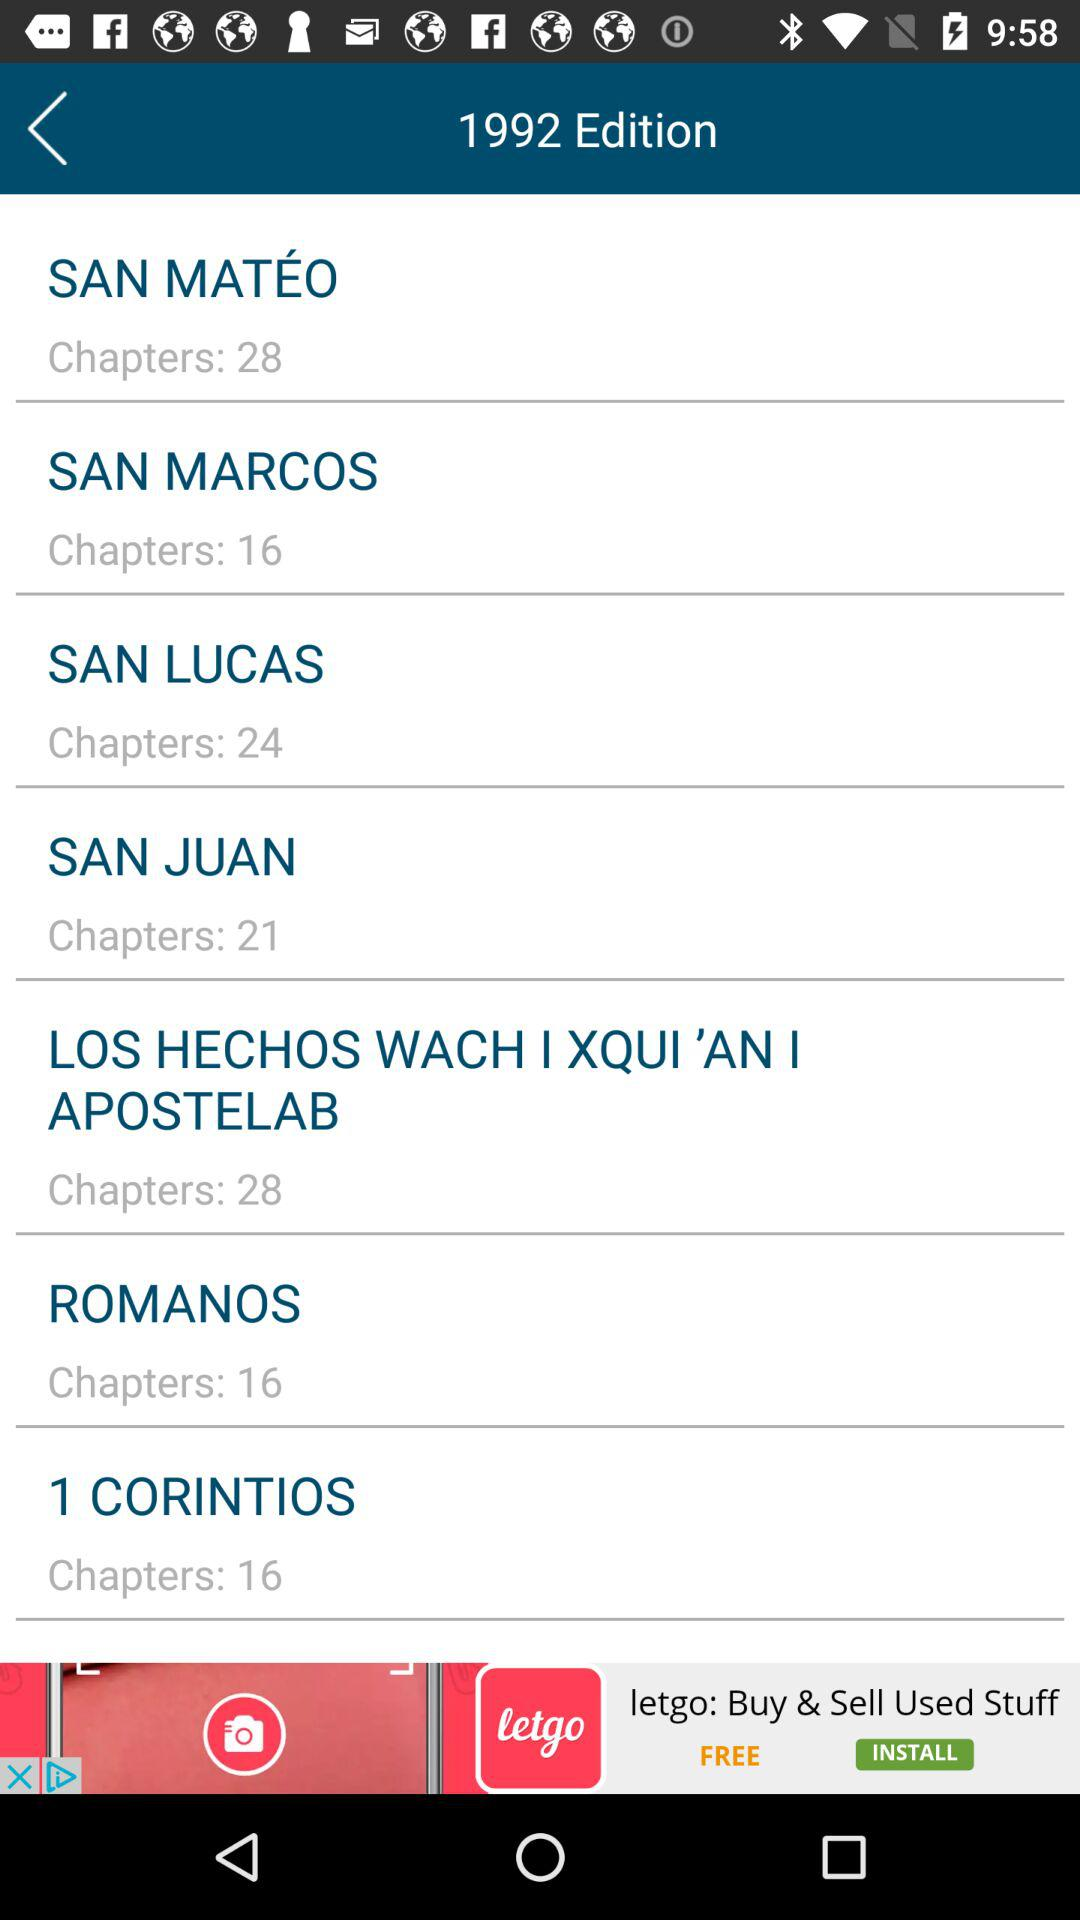What is the number of chapters in San Marcos? There are 16 chapters. 